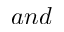<formula> <loc_0><loc_0><loc_500><loc_500>a n d</formula> 